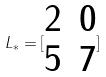Convert formula to latex. <formula><loc_0><loc_0><loc_500><loc_500>L _ { * } = [ \begin{matrix} 2 & 0 \\ 5 & 7 \\ \end{matrix} ]</formula> 